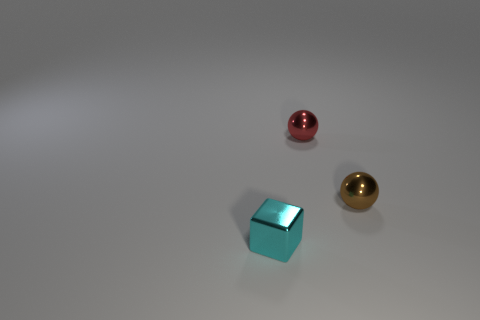How many cyan things have the same size as the red metal sphere?
Keep it short and to the point. 1. What material is the small thing that is both behind the cyan shiny cube and to the left of the brown object?
Your answer should be compact. Metal. How many objects are in front of the small red thing?
Your answer should be very brief. 2. Do the small cyan metallic thing and the shiny thing on the right side of the small red metal sphere have the same shape?
Offer a very short reply. No. Are there any other cyan metallic objects that have the same shape as the cyan thing?
Your answer should be compact. No. The shiny object that is behind the tiny sphere in front of the red sphere is what shape?
Give a very brief answer. Sphere. There is a small thing in front of the tiny brown metallic sphere; what is its shape?
Ensure brevity in your answer.  Cube. Does the tiny sphere that is on the right side of the tiny red object have the same color as the metal thing behind the tiny brown ball?
Ensure brevity in your answer.  No. What number of things are in front of the small red object and on the right side of the shiny cube?
Make the answer very short. 1. What is the size of the brown thing that is made of the same material as the block?
Provide a short and direct response. Small. 